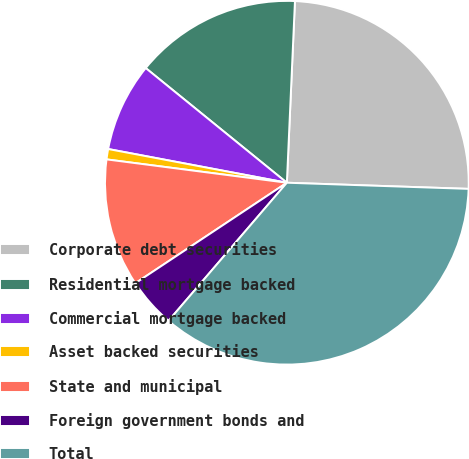Convert chart. <chart><loc_0><loc_0><loc_500><loc_500><pie_chart><fcel>Corporate debt securities<fcel>Residential mortgage backed<fcel>Commercial mortgage backed<fcel>Asset backed securities<fcel>State and municipal<fcel>Foreign government bonds and<fcel>Total<nl><fcel>24.83%<fcel>14.85%<fcel>7.89%<fcel>0.92%<fcel>11.37%<fcel>4.4%<fcel>35.74%<nl></chart> 